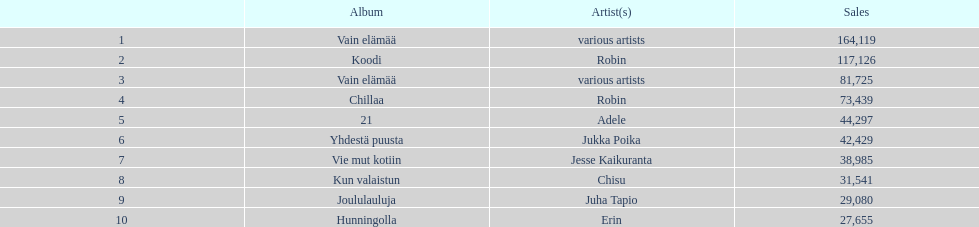Can you parse all the data within this table? {'header': ['', 'Album', 'Artist(s)', 'Sales'], 'rows': [['1', 'Vain elämää', 'various artists', '164,119'], ['2', 'Koodi', 'Robin', '117,126'], ['3', 'Vain elämää', 'various artists', '81,725'], ['4', 'Chillaa', 'Robin', '73,439'], ['5', '21', 'Adele', '44,297'], ['6', 'Yhdestä puusta', 'Jukka Poika', '42,429'], ['7', 'Vie mut kotiin', 'Jesse Kaikuranta', '38,985'], ['8', 'Kun valaistun', 'Chisu', '31,541'], ['9', 'Joululauluja', 'Juha Tapio', '29,080'], ['10', 'Hunningolla', 'Erin', '27,655']]} Which was the last album to sell over 100,000 records? Koodi. 